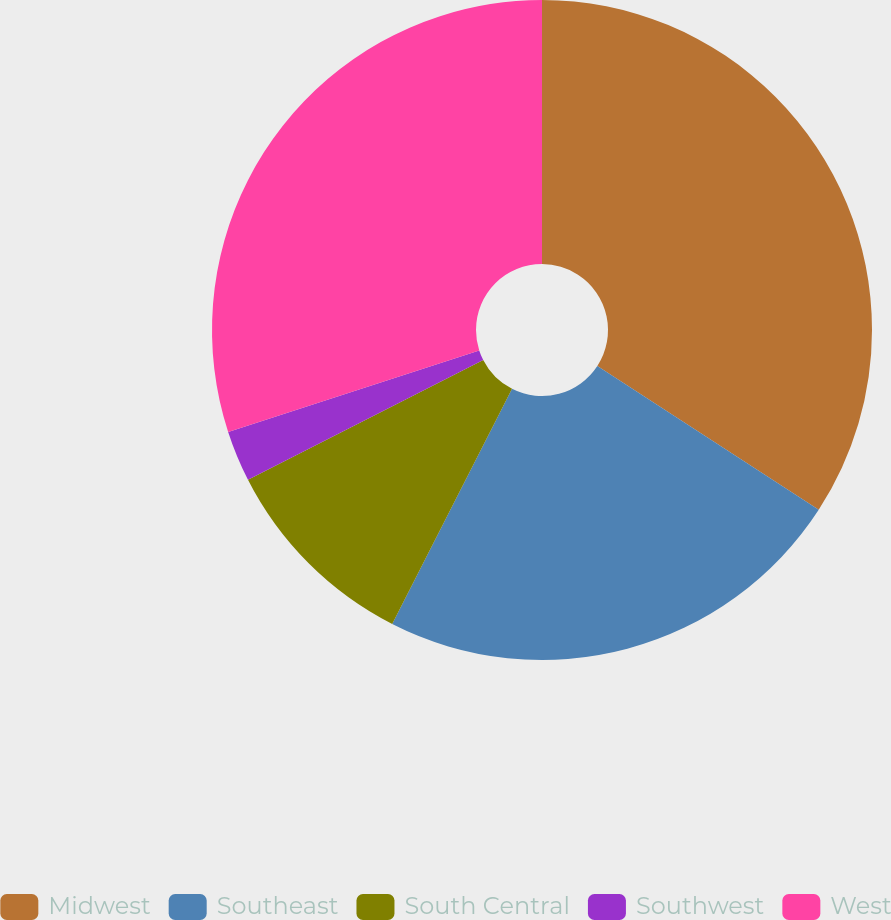Convert chart to OTSL. <chart><loc_0><loc_0><loc_500><loc_500><pie_chart><fcel>Midwest<fcel>Southeast<fcel>South Central<fcel>Southwest<fcel>West<nl><fcel>34.17%<fcel>23.33%<fcel>10.0%<fcel>2.5%<fcel>30.0%<nl></chart> 